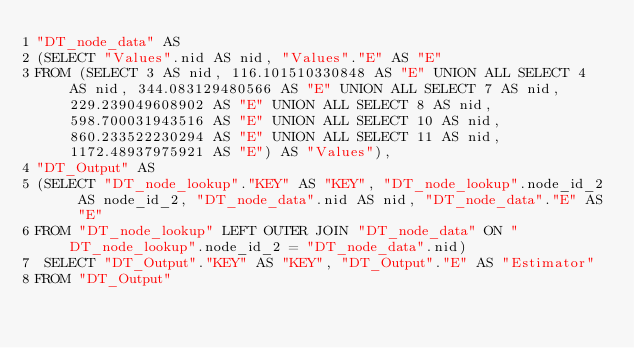<code> <loc_0><loc_0><loc_500><loc_500><_SQL_>"DT_node_data" AS 
(SELECT "Values".nid AS nid, "Values"."E" AS "E" 
FROM (SELECT 3 AS nid, 116.101510330848 AS "E" UNION ALL SELECT 4 AS nid, 344.083129480566 AS "E" UNION ALL SELECT 7 AS nid, 229.239049608902 AS "E" UNION ALL SELECT 8 AS nid, 598.700031943516 AS "E" UNION ALL SELECT 10 AS nid, 860.233522230294 AS "E" UNION ALL SELECT 11 AS nid, 1172.48937975921 AS "E") AS "Values"), 
"DT_Output" AS 
(SELECT "DT_node_lookup"."KEY" AS "KEY", "DT_node_lookup".node_id_2 AS node_id_2, "DT_node_data".nid AS nid, "DT_node_data"."E" AS "E" 
FROM "DT_node_lookup" LEFT OUTER JOIN "DT_node_data" ON "DT_node_lookup".node_id_2 = "DT_node_data".nid)
 SELECT "DT_Output"."KEY" AS "KEY", "DT_Output"."E" AS "Estimator" 
FROM "DT_Output"</code> 